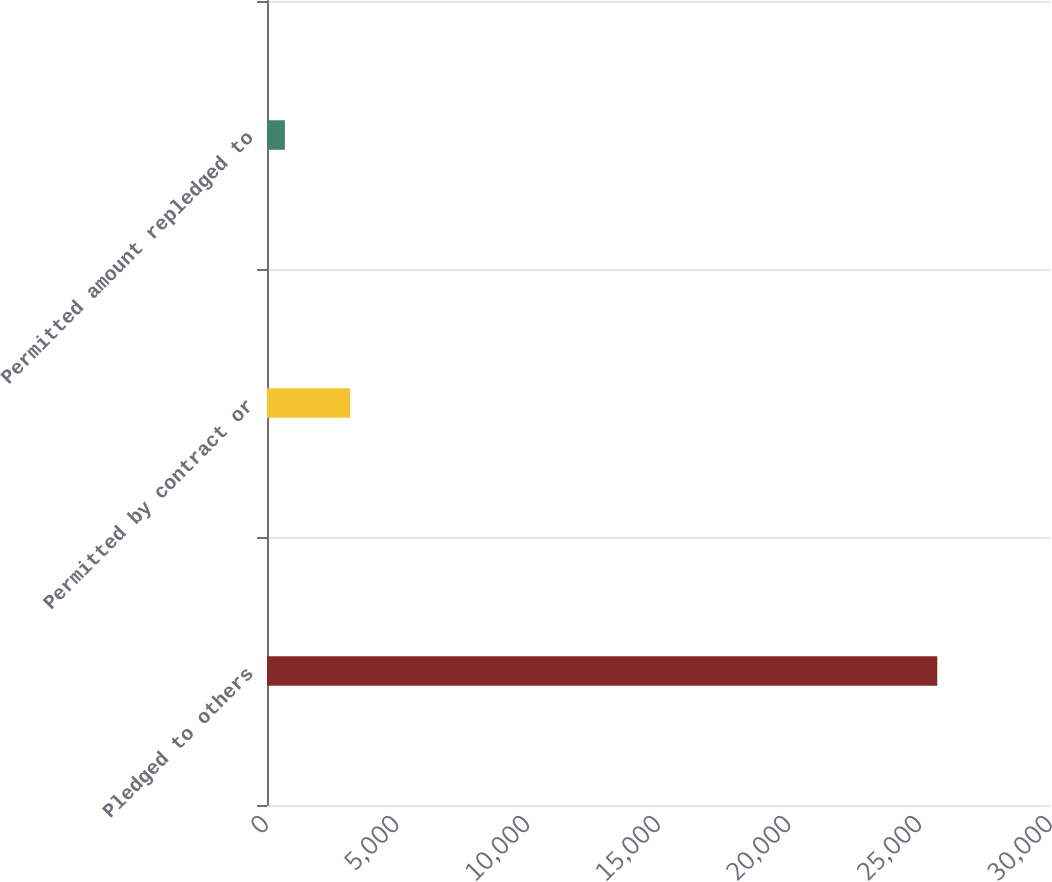Convert chart to OTSL. <chart><loc_0><loc_0><loc_500><loc_500><bar_chart><fcel>Pledged to others<fcel>Permitted by contract or<fcel>Permitted amount repledged to<nl><fcel>25648<fcel>3181.3<fcel>685<nl></chart> 